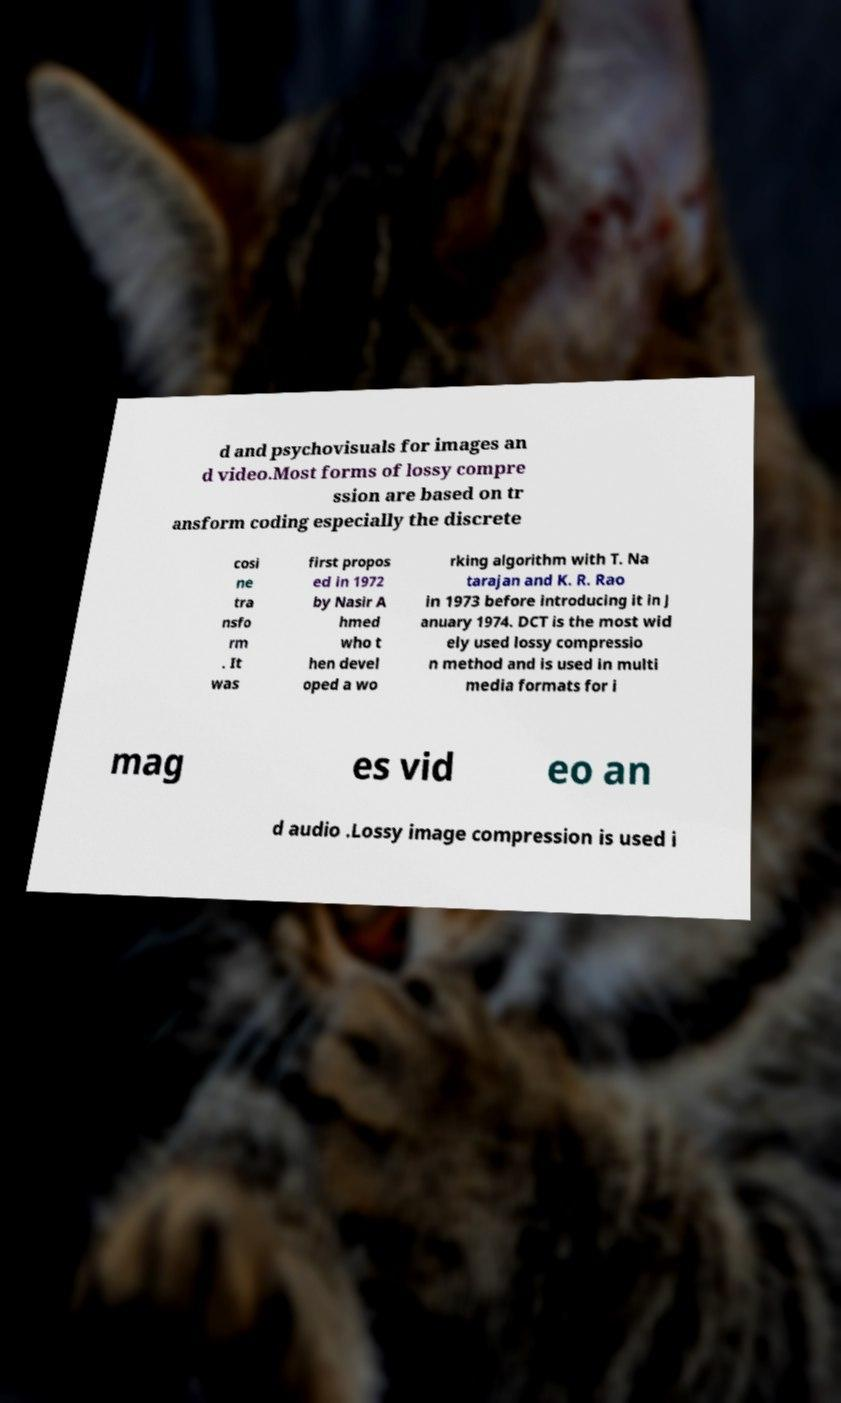For documentation purposes, I need the text within this image transcribed. Could you provide that? d and psychovisuals for images an d video.Most forms of lossy compre ssion are based on tr ansform coding especially the discrete cosi ne tra nsfo rm . It was first propos ed in 1972 by Nasir A hmed who t hen devel oped a wo rking algorithm with T. Na tarajan and K. R. Rao in 1973 before introducing it in J anuary 1974. DCT is the most wid ely used lossy compressio n method and is used in multi media formats for i mag es vid eo an d audio .Lossy image compression is used i 